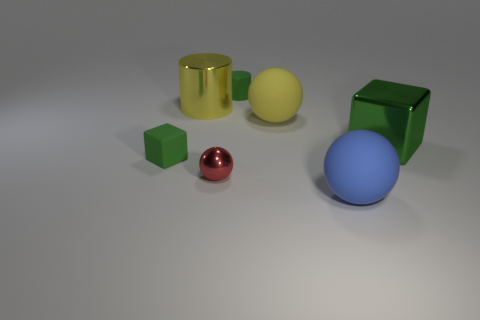Are there any other things that are the same color as the small matte block?
Provide a short and direct response. Yes. What is the color of the large rubber ball that is in front of the green cube on the left side of the yellow metallic object?
Give a very brief answer. Blue. How many small objects are green metal cubes or purple metallic blocks?
Ensure brevity in your answer.  0. There is a big yellow thing that is the same shape as the blue thing; what material is it?
Your response must be concise. Rubber. Is there any other thing that is made of the same material as the blue thing?
Offer a terse response. Yes. What color is the tiny rubber cylinder?
Offer a terse response. Green. Do the big shiny block and the large metallic cylinder have the same color?
Give a very brief answer. No. There is a large object in front of the large block; how many tiny red balls are in front of it?
Keep it short and to the point. 0. There is a green object that is in front of the big yellow metallic cylinder and to the right of the large shiny cylinder; how big is it?
Your response must be concise. Large. What is the green cube that is on the right side of the large blue rubber object made of?
Make the answer very short. Metal. 